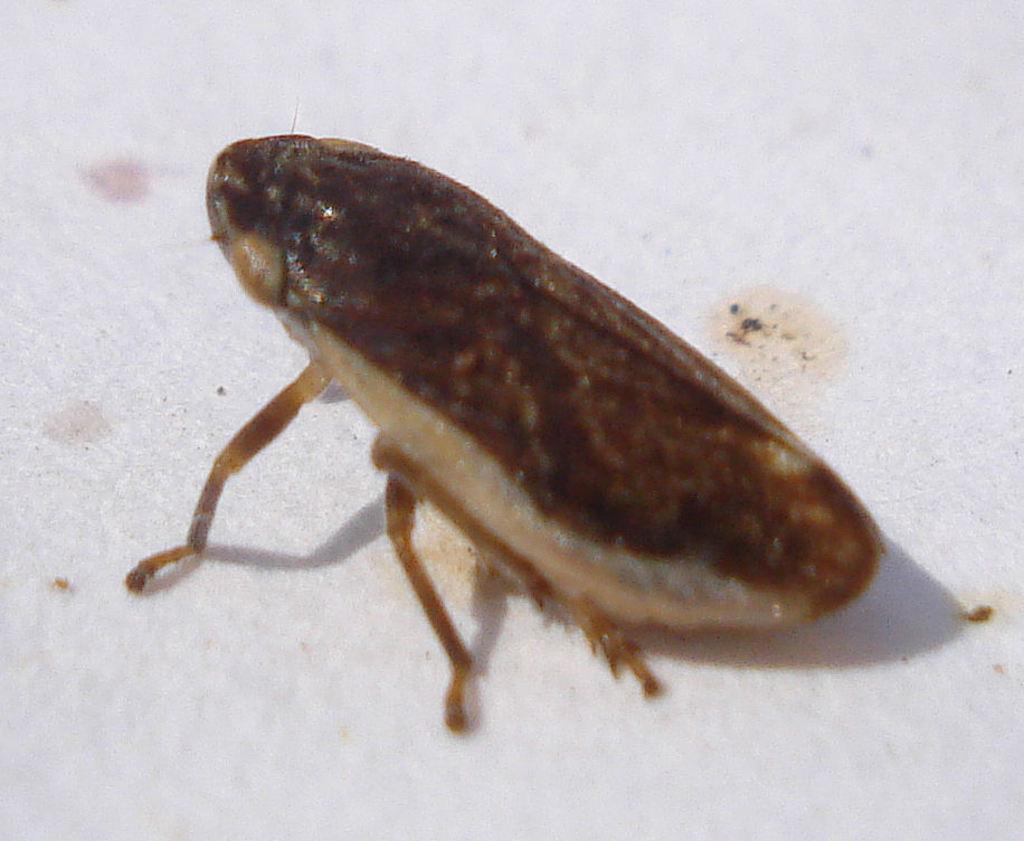Could you give a brief overview of what you see in this image? In the image we can see there is an insect. 